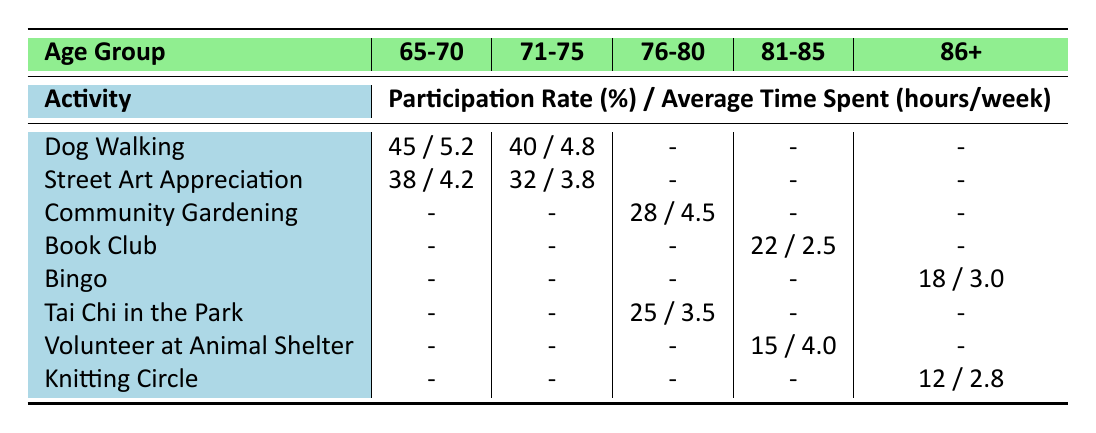What is the participation rate for Dog Walking among the 65-70 age group? The table shows that the participation rate for Dog Walking in the 65-70 age group is listed directly as 45%.
Answer: 45% Which activity has the highest average time spent per week in the 71-75 age group? The average time spent for Street Art Appreciation is 3.8 hours and for Dog Walking is 4.8 hours, so Dog Walking has the highest average time spent in the 71-75 age group.
Answer: Dog Walking Is there an activity that the 86+ age group participates in with a participation rate greater than 15%? The table indicates that the Bingo activity has a participation rate of 18%, which is greater than 15%.
Answer: Yes What is the difference in participation rates between the 65-70 and 71-75 age groups for the Dog Walking activity? The participation rate for Dog Walking in the 65-70 age group is 45% while in the 71-75 age group it is 40%. Therefore, the difference is 45% - 40% = 5%.
Answer: 5% How many activities have a participation rate of less than 20%? In the table, Book Club and Knitting Circle are the only activities with participation rates below 20%, those being 22% and 12%. Thus, the count of activities below 20% is 2.
Answer: 2 What is the average participation rate for all the activities in the 76-80 age group? The activities for the 76-80 age group are Community Gardening (28%), Tai Chi in the Park (25%). The average is calculated as (28 + 25) / 2 = 26.5%.
Answer: 26.5% Is the participation rate for Street Art Appreciation higher among females or males in the 65-70 age group? The participation rate for males in this age group is 38% while for females it is 45%, indicating that females have a higher participation rate in this activity.
Answer: Females Which age group spends the least average time on activities overall? The table shows that the 81-85 age group has the least average time spent, which is 2.5 hours/week for the Book Club. There are no entries for the other age groups with lower time spent than this.
Answer: 2.5 hours/week In which neighborhood does the 76-80 age group participate in Community Gardening? The table specifies that the 76-80 age group participates in Community Gardening in Noe Valley.
Answer: Noe Valley 